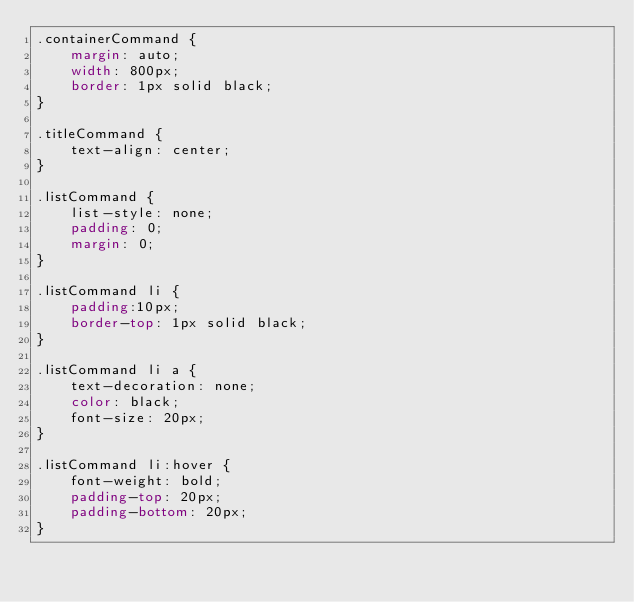Convert code to text. <code><loc_0><loc_0><loc_500><loc_500><_CSS_>.containerCommand {
    margin: auto;
    width: 800px;
    border: 1px solid black;
}

.titleCommand {
    text-align: center;
}

.listCommand {
    list-style: none;
    padding: 0;
    margin: 0;
}

.listCommand li {
    padding:10px;
    border-top: 1px solid black;
}

.listCommand li a {
    text-decoration: none;
    color: black;
    font-size: 20px;
}

.listCommand li:hover {
    font-weight: bold;
    padding-top: 20px;
    padding-bottom: 20px;
}</code> 